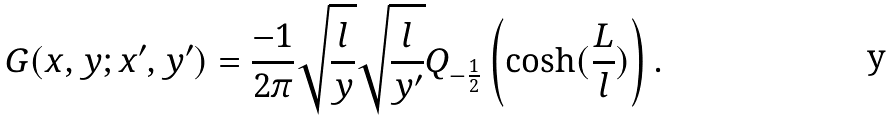<formula> <loc_0><loc_0><loc_500><loc_500>G ( x , y ; x ^ { \prime } , y ^ { \prime } ) = \frac { - 1 } { 2 \pi } \sqrt { \frac { l } { y } } \sqrt { \frac { l } { y ^ { \prime } } } Q _ { - \frac { 1 } { 2 } } \left ( \cosh ( \frac { L } { l } ) \right ) .</formula> 